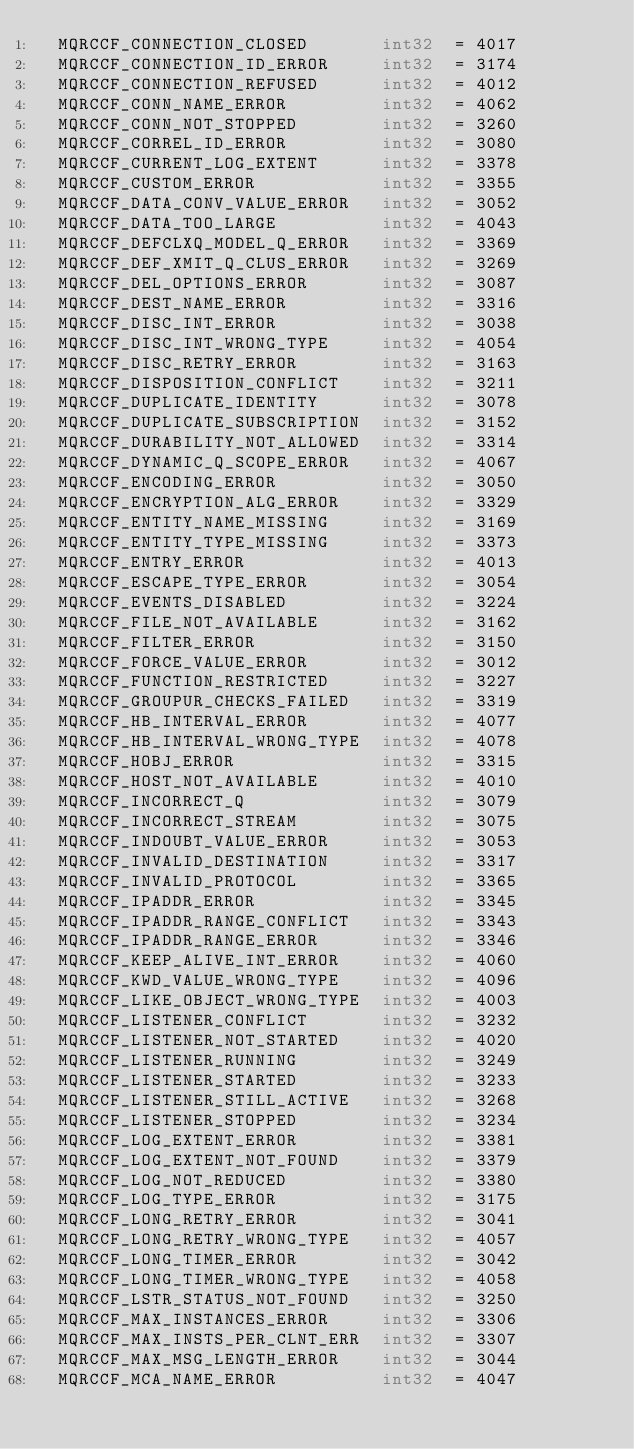<code> <loc_0><loc_0><loc_500><loc_500><_Go_>	MQRCCF_CONNECTION_CLOSED       int32  = 4017
	MQRCCF_CONNECTION_ID_ERROR     int32  = 3174
	MQRCCF_CONNECTION_REFUSED      int32  = 4012
	MQRCCF_CONN_NAME_ERROR         int32  = 4062
	MQRCCF_CONN_NOT_STOPPED        int32  = 3260
	MQRCCF_CORREL_ID_ERROR         int32  = 3080
	MQRCCF_CURRENT_LOG_EXTENT      int32  = 3378
	MQRCCF_CUSTOM_ERROR            int32  = 3355
	MQRCCF_DATA_CONV_VALUE_ERROR   int32  = 3052
	MQRCCF_DATA_TOO_LARGE          int32  = 4043
	MQRCCF_DEFCLXQ_MODEL_Q_ERROR   int32  = 3369
	MQRCCF_DEF_XMIT_Q_CLUS_ERROR   int32  = 3269
	MQRCCF_DEL_OPTIONS_ERROR       int32  = 3087
	MQRCCF_DEST_NAME_ERROR         int32  = 3316
	MQRCCF_DISC_INT_ERROR          int32  = 3038
	MQRCCF_DISC_INT_WRONG_TYPE     int32  = 4054
	MQRCCF_DISC_RETRY_ERROR        int32  = 3163
	MQRCCF_DISPOSITION_CONFLICT    int32  = 3211
	MQRCCF_DUPLICATE_IDENTITY      int32  = 3078
	MQRCCF_DUPLICATE_SUBSCRIPTION  int32  = 3152
	MQRCCF_DURABILITY_NOT_ALLOWED  int32  = 3314
	MQRCCF_DYNAMIC_Q_SCOPE_ERROR   int32  = 4067
	MQRCCF_ENCODING_ERROR          int32  = 3050
	MQRCCF_ENCRYPTION_ALG_ERROR    int32  = 3329
	MQRCCF_ENTITY_NAME_MISSING     int32  = 3169
	MQRCCF_ENTITY_TYPE_MISSING     int32  = 3373
	MQRCCF_ENTRY_ERROR             int32  = 4013
	MQRCCF_ESCAPE_TYPE_ERROR       int32  = 3054
	MQRCCF_EVENTS_DISABLED         int32  = 3224
	MQRCCF_FILE_NOT_AVAILABLE      int32  = 3162
	MQRCCF_FILTER_ERROR            int32  = 3150
	MQRCCF_FORCE_VALUE_ERROR       int32  = 3012
	MQRCCF_FUNCTION_RESTRICTED     int32  = 3227
	MQRCCF_GROUPUR_CHECKS_FAILED   int32  = 3319
	MQRCCF_HB_INTERVAL_ERROR       int32  = 4077
	MQRCCF_HB_INTERVAL_WRONG_TYPE  int32  = 4078
	MQRCCF_HOBJ_ERROR              int32  = 3315
	MQRCCF_HOST_NOT_AVAILABLE      int32  = 4010
	MQRCCF_INCORRECT_Q             int32  = 3079
	MQRCCF_INCORRECT_STREAM        int32  = 3075
	MQRCCF_INDOUBT_VALUE_ERROR     int32  = 3053
	MQRCCF_INVALID_DESTINATION     int32  = 3317
	MQRCCF_INVALID_PROTOCOL        int32  = 3365
	MQRCCF_IPADDR_ERROR            int32  = 3345
	MQRCCF_IPADDR_RANGE_CONFLICT   int32  = 3343
	MQRCCF_IPADDR_RANGE_ERROR      int32  = 3346
	MQRCCF_KEEP_ALIVE_INT_ERROR    int32  = 4060
	MQRCCF_KWD_VALUE_WRONG_TYPE    int32  = 4096
	MQRCCF_LIKE_OBJECT_WRONG_TYPE  int32  = 4003
	MQRCCF_LISTENER_CONFLICT       int32  = 3232
	MQRCCF_LISTENER_NOT_STARTED    int32  = 4020
	MQRCCF_LISTENER_RUNNING        int32  = 3249
	MQRCCF_LISTENER_STARTED        int32  = 3233
	MQRCCF_LISTENER_STILL_ACTIVE   int32  = 3268
	MQRCCF_LISTENER_STOPPED        int32  = 3234
	MQRCCF_LOG_EXTENT_ERROR        int32  = 3381
	MQRCCF_LOG_EXTENT_NOT_FOUND    int32  = 3379
	MQRCCF_LOG_NOT_REDUCED         int32  = 3380
	MQRCCF_LOG_TYPE_ERROR          int32  = 3175
	MQRCCF_LONG_RETRY_ERROR        int32  = 3041
	MQRCCF_LONG_RETRY_WRONG_TYPE   int32  = 4057
	MQRCCF_LONG_TIMER_ERROR        int32  = 3042
	MQRCCF_LONG_TIMER_WRONG_TYPE   int32  = 4058
	MQRCCF_LSTR_STATUS_NOT_FOUND   int32  = 3250
	MQRCCF_MAX_INSTANCES_ERROR     int32  = 3306
	MQRCCF_MAX_INSTS_PER_CLNT_ERR  int32  = 3307
	MQRCCF_MAX_MSG_LENGTH_ERROR    int32  = 3044
	MQRCCF_MCA_NAME_ERROR          int32  = 4047</code> 